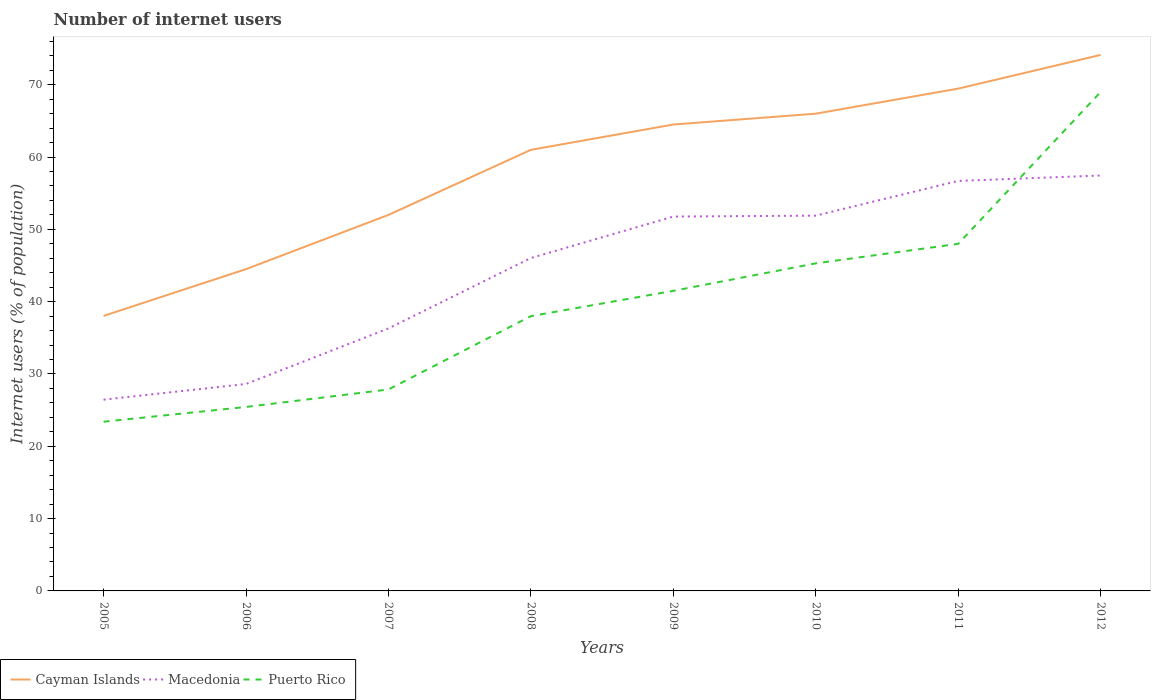Is the number of lines equal to the number of legend labels?
Offer a terse response. Yes. Across all years, what is the maximum number of internet users in Cayman Islands?
Provide a succinct answer. 38.03. What is the total number of internet users in Cayman Islands in the graph?
Offer a terse response. -36.09. What is the difference between the highest and the second highest number of internet users in Macedonia?
Provide a succinct answer. 31. What is the difference between the highest and the lowest number of internet users in Macedonia?
Offer a terse response. 5. Is the number of internet users in Macedonia strictly greater than the number of internet users in Puerto Rico over the years?
Your answer should be compact. No. How many lines are there?
Make the answer very short. 3. How many years are there in the graph?
Ensure brevity in your answer.  8. Are the values on the major ticks of Y-axis written in scientific E-notation?
Offer a very short reply. No. What is the title of the graph?
Your answer should be very brief. Number of internet users. Does "Spain" appear as one of the legend labels in the graph?
Offer a very short reply. No. What is the label or title of the Y-axis?
Ensure brevity in your answer.  Internet users (% of population). What is the Internet users (% of population) of Cayman Islands in 2005?
Offer a very short reply. 38.03. What is the Internet users (% of population) in Macedonia in 2005?
Give a very brief answer. 26.45. What is the Internet users (% of population) in Puerto Rico in 2005?
Offer a terse response. 23.4. What is the Internet users (% of population) of Cayman Islands in 2006?
Ensure brevity in your answer.  44.5. What is the Internet users (% of population) in Macedonia in 2006?
Your answer should be very brief. 28.62. What is the Internet users (% of population) of Puerto Rico in 2006?
Give a very brief answer. 25.44. What is the Internet users (% of population) of Cayman Islands in 2007?
Provide a succinct answer. 52. What is the Internet users (% of population) in Macedonia in 2007?
Give a very brief answer. 36.3. What is the Internet users (% of population) in Puerto Rico in 2007?
Ensure brevity in your answer.  27.86. What is the Internet users (% of population) of Macedonia in 2008?
Your answer should be compact. 46.04. What is the Internet users (% of population) of Puerto Rico in 2008?
Give a very brief answer. 38. What is the Internet users (% of population) in Cayman Islands in 2009?
Your answer should be very brief. 64.5. What is the Internet users (% of population) in Macedonia in 2009?
Offer a terse response. 51.77. What is the Internet users (% of population) in Puerto Rico in 2009?
Offer a terse response. 41.5. What is the Internet users (% of population) in Macedonia in 2010?
Offer a very short reply. 51.9. What is the Internet users (% of population) of Puerto Rico in 2010?
Ensure brevity in your answer.  45.3. What is the Internet users (% of population) of Cayman Islands in 2011?
Ensure brevity in your answer.  69.47. What is the Internet users (% of population) of Macedonia in 2011?
Provide a short and direct response. 56.7. What is the Internet users (% of population) in Cayman Islands in 2012?
Offer a terse response. 74.13. What is the Internet users (% of population) of Macedonia in 2012?
Offer a very short reply. 57.45. What is the Internet users (% of population) in Puerto Rico in 2012?
Provide a short and direct response. 69. Across all years, what is the maximum Internet users (% of population) of Cayman Islands?
Ensure brevity in your answer.  74.13. Across all years, what is the maximum Internet users (% of population) in Macedonia?
Ensure brevity in your answer.  57.45. Across all years, what is the maximum Internet users (% of population) of Puerto Rico?
Keep it short and to the point. 69. Across all years, what is the minimum Internet users (% of population) in Cayman Islands?
Keep it short and to the point. 38.03. Across all years, what is the minimum Internet users (% of population) of Macedonia?
Offer a terse response. 26.45. Across all years, what is the minimum Internet users (% of population) of Puerto Rico?
Your answer should be very brief. 23.4. What is the total Internet users (% of population) in Cayman Islands in the graph?
Give a very brief answer. 469.63. What is the total Internet users (% of population) of Macedonia in the graph?
Provide a succinct answer. 355.23. What is the total Internet users (% of population) of Puerto Rico in the graph?
Your answer should be very brief. 318.5. What is the difference between the Internet users (% of population) in Cayman Islands in 2005 and that in 2006?
Your answer should be very brief. -6.47. What is the difference between the Internet users (% of population) of Macedonia in 2005 and that in 2006?
Give a very brief answer. -2.17. What is the difference between the Internet users (% of population) in Puerto Rico in 2005 and that in 2006?
Your answer should be compact. -2.04. What is the difference between the Internet users (% of population) in Cayman Islands in 2005 and that in 2007?
Keep it short and to the point. -13.97. What is the difference between the Internet users (% of population) of Macedonia in 2005 and that in 2007?
Provide a succinct answer. -9.85. What is the difference between the Internet users (% of population) in Puerto Rico in 2005 and that in 2007?
Your answer should be very brief. -4.46. What is the difference between the Internet users (% of population) in Cayman Islands in 2005 and that in 2008?
Your answer should be compact. -22.97. What is the difference between the Internet users (% of population) in Macedonia in 2005 and that in 2008?
Your answer should be compact. -19.59. What is the difference between the Internet users (% of population) of Puerto Rico in 2005 and that in 2008?
Offer a very short reply. -14.6. What is the difference between the Internet users (% of population) of Cayman Islands in 2005 and that in 2009?
Keep it short and to the point. -26.47. What is the difference between the Internet users (% of population) in Macedonia in 2005 and that in 2009?
Offer a very short reply. -25.32. What is the difference between the Internet users (% of population) in Puerto Rico in 2005 and that in 2009?
Provide a succinct answer. -18.1. What is the difference between the Internet users (% of population) in Cayman Islands in 2005 and that in 2010?
Provide a succinct answer. -27.97. What is the difference between the Internet users (% of population) of Macedonia in 2005 and that in 2010?
Provide a succinct answer. -25.45. What is the difference between the Internet users (% of population) in Puerto Rico in 2005 and that in 2010?
Provide a short and direct response. -21.9. What is the difference between the Internet users (% of population) in Cayman Islands in 2005 and that in 2011?
Offer a very short reply. -31.43. What is the difference between the Internet users (% of population) of Macedonia in 2005 and that in 2011?
Your answer should be very brief. -30.25. What is the difference between the Internet users (% of population) of Puerto Rico in 2005 and that in 2011?
Make the answer very short. -24.6. What is the difference between the Internet users (% of population) of Cayman Islands in 2005 and that in 2012?
Provide a succinct answer. -36.09. What is the difference between the Internet users (% of population) in Macedonia in 2005 and that in 2012?
Your answer should be very brief. -31. What is the difference between the Internet users (% of population) of Puerto Rico in 2005 and that in 2012?
Ensure brevity in your answer.  -45.6. What is the difference between the Internet users (% of population) in Macedonia in 2006 and that in 2007?
Your answer should be compact. -7.68. What is the difference between the Internet users (% of population) in Puerto Rico in 2006 and that in 2007?
Offer a terse response. -2.42. What is the difference between the Internet users (% of population) in Cayman Islands in 2006 and that in 2008?
Your answer should be compact. -16.5. What is the difference between the Internet users (% of population) in Macedonia in 2006 and that in 2008?
Provide a short and direct response. -17.42. What is the difference between the Internet users (% of population) in Puerto Rico in 2006 and that in 2008?
Ensure brevity in your answer.  -12.56. What is the difference between the Internet users (% of population) of Cayman Islands in 2006 and that in 2009?
Offer a very short reply. -20. What is the difference between the Internet users (% of population) in Macedonia in 2006 and that in 2009?
Provide a short and direct response. -23.15. What is the difference between the Internet users (% of population) of Puerto Rico in 2006 and that in 2009?
Give a very brief answer. -16.06. What is the difference between the Internet users (% of population) of Cayman Islands in 2006 and that in 2010?
Your answer should be compact. -21.5. What is the difference between the Internet users (% of population) in Macedonia in 2006 and that in 2010?
Your response must be concise. -23.28. What is the difference between the Internet users (% of population) in Puerto Rico in 2006 and that in 2010?
Give a very brief answer. -19.86. What is the difference between the Internet users (% of population) in Cayman Islands in 2006 and that in 2011?
Offer a terse response. -24.97. What is the difference between the Internet users (% of population) in Macedonia in 2006 and that in 2011?
Give a very brief answer. -28.08. What is the difference between the Internet users (% of population) in Puerto Rico in 2006 and that in 2011?
Your answer should be very brief. -22.56. What is the difference between the Internet users (% of population) in Cayman Islands in 2006 and that in 2012?
Provide a short and direct response. -29.63. What is the difference between the Internet users (% of population) of Macedonia in 2006 and that in 2012?
Provide a short and direct response. -28.83. What is the difference between the Internet users (% of population) of Puerto Rico in 2006 and that in 2012?
Give a very brief answer. -43.56. What is the difference between the Internet users (% of population) in Cayman Islands in 2007 and that in 2008?
Your response must be concise. -9. What is the difference between the Internet users (% of population) in Macedonia in 2007 and that in 2008?
Give a very brief answer. -9.74. What is the difference between the Internet users (% of population) of Puerto Rico in 2007 and that in 2008?
Provide a succinct answer. -10.14. What is the difference between the Internet users (% of population) in Macedonia in 2007 and that in 2009?
Keep it short and to the point. -15.47. What is the difference between the Internet users (% of population) in Puerto Rico in 2007 and that in 2009?
Keep it short and to the point. -13.64. What is the difference between the Internet users (% of population) in Cayman Islands in 2007 and that in 2010?
Offer a terse response. -14. What is the difference between the Internet users (% of population) of Macedonia in 2007 and that in 2010?
Make the answer very short. -15.6. What is the difference between the Internet users (% of population) of Puerto Rico in 2007 and that in 2010?
Provide a succinct answer. -17.44. What is the difference between the Internet users (% of population) in Cayman Islands in 2007 and that in 2011?
Keep it short and to the point. -17.47. What is the difference between the Internet users (% of population) of Macedonia in 2007 and that in 2011?
Provide a short and direct response. -20.4. What is the difference between the Internet users (% of population) of Puerto Rico in 2007 and that in 2011?
Ensure brevity in your answer.  -20.14. What is the difference between the Internet users (% of population) of Cayman Islands in 2007 and that in 2012?
Provide a succinct answer. -22.13. What is the difference between the Internet users (% of population) of Macedonia in 2007 and that in 2012?
Provide a succinct answer. -21.15. What is the difference between the Internet users (% of population) in Puerto Rico in 2007 and that in 2012?
Your answer should be compact. -41.14. What is the difference between the Internet users (% of population) in Macedonia in 2008 and that in 2009?
Your response must be concise. -5.73. What is the difference between the Internet users (% of population) in Puerto Rico in 2008 and that in 2009?
Give a very brief answer. -3.5. What is the difference between the Internet users (% of population) of Cayman Islands in 2008 and that in 2010?
Your answer should be very brief. -5. What is the difference between the Internet users (% of population) of Macedonia in 2008 and that in 2010?
Your response must be concise. -5.86. What is the difference between the Internet users (% of population) of Puerto Rico in 2008 and that in 2010?
Your answer should be very brief. -7.3. What is the difference between the Internet users (% of population) of Cayman Islands in 2008 and that in 2011?
Make the answer very short. -8.47. What is the difference between the Internet users (% of population) in Macedonia in 2008 and that in 2011?
Offer a terse response. -10.66. What is the difference between the Internet users (% of population) of Cayman Islands in 2008 and that in 2012?
Offer a terse response. -13.13. What is the difference between the Internet users (% of population) in Macedonia in 2008 and that in 2012?
Give a very brief answer. -11.41. What is the difference between the Internet users (% of population) of Puerto Rico in 2008 and that in 2012?
Offer a very short reply. -31. What is the difference between the Internet users (% of population) in Cayman Islands in 2009 and that in 2010?
Offer a terse response. -1.5. What is the difference between the Internet users (% of population) in Macedonia in 2009 and that in 2010?
Ensure brevity in your answer.  -0.13. What is the difference between the Internet users (% of population) of Cayman Islands in 2009 and that in 2011?
Offer a very short reply. -4.97. What is the difference between the Internet users (% of population) of Macedonia in 2009 and that in 2011?
Ensure brevity in your answer.  -4.93. What is the difference between the Internet users (% of population) in Cayman Islands in 2009 and that in 2012?
Ensure brevity in your answer.  -9.63. What is the difference between the Internet users (% of population) of Macedonia in 2009 and that in 2012?
Make the answer very short. -5.68. What is the difference between the Internet users (% of population) of Puerto Rico in 2009 and that in 2012?
Give a very brief answer. -27.5. What is the difference between the Internet users (% of population) of Cayman Islands in 2010 and that in 2011?
Your answer should be very brief. -3.47. What is the difference between the Internet users (% of population) in Macedonia in 2010 and that in 2011?
Your answer should be compact. -4.8. What is the difference between the Internet users (% of population) of Cayman Islands in 2010 and that in 2012?
Keep it short and to the point. -8.13. What is the difference between the Internet users (% of population) of Macedonia in 2010 and that in 2012?
Keep it short and to the point. -5.55. What is the difference between the Internet users (% of population) in Puerto Rico in 2010 and that in 2012?
Give a very brief answer. -23.7. What is the difference between the Internet users (% of population) of Cayman Islands in 2011 and that in 2012?
Offer a very short reply. -4.66. What is the difference between the Internet users (% of population) in Macedonia in 2011 and that in 2012?
Keep it short and to the point. -0.75. What is the difference between the Internet users (% of population) of Cayman Islands in 2005 and the Internet users (% of population) of Macedonia in 2006?
Provide a short and direct response. 9.41. What is the difference between the Internet users (% of population) of Cayman Islands in 2005 and the Internet users (% of population) of Puerto Rico in 2006?
Your response must be concise. 12.59. What is the difference between the Internet users (% of population) in Macedonia in 2005 and the Internet users (% of population) in Puerto Rico in 2006?
Give a very brief answer. 1.01. What is the difference between the Internet users (% of population) in Cayman Islands in 2005 and the Internet users (% of population) in Macedonia in 2007?
Keep it short and to the point. 1.73. What is the difference between the Internet users (% of population) in Cayman Islands in 2005 and the Internet users (% of population) in Puerto Rico in 2007?
Ensure brevity in your answer.  10.17. What is the difference between the Internet users (% of population) in Macedonia in 2005 and the Internet users (% of population) in Puerto Rico in 2007?
Your answer should be very brief. -1.41. What is the difference between the Internet users (% of population) in Cayman Islands in 2005 and the Internet users (% of population) in Macedonia in 2008?
Keep it short and to the point. -8.01. What is the difference between the Internet users (% of population) in Cayman Islands in 2005 and the Internet users (% of population) in Puerto Rico in 2008?
Give a very brief answer. 0.03. What is the difference between the Internet users (% of population) in Macedonia in 2005 and the Internet users (% of population) in Puerto Rico in 2008?
Your response must be concise. -11.55. What is the difference between the Internet users (% of population) in Cayman Islands in 2005 and the Internet users (% of population) in Macedonia in 2009?
Make the answer very short. -13.74. What is the difference between the Internet users (% of population) of Cayman Islands in 2005 and the Internet users (% of population) of Puerto Rico in 2009?
Your answer should be compact. -3.47. What is the difference between the Internet users (% of population) of Macedonia in 2005 and the Internet users (% of population) of Puerto Rico in 2009?
Provide a short and direct response. -15.05. What is the difference between the Internet users (% of population) in Cayman Islands in 2005 and the Internet users (% of population) in Macedonia in 2010?
Your response must be concise. -13.87. What is the difference between the Internet users (% of population) of Cayman Islands in 2005 and the Internet users (% of population) of Puerto Rico in 2010?
Your response must be concise. -7.27. What is the difference between the Internet users (% of population) of Macedonia in 2005 and the Internet users (% of population) of Puerto Rico in 2010?
Keep it short and to the point. -18.85. What is the difference between the Internet users (% of population) of Cayman Islands in 2005 and the Internet users (% of population) of Macedonia in 2011?
Offer a terse response. -18.67. What is the difference between the Internet users (% of population) of Cayman Islands in 2005 and the Internet users (% of population) of Puerto Rico in 2011?
Ensure brevity in your answer.  -9.97. What is the difference between the Internet users (% of population) of Macedonia in 2005 and the Internet users (% of population) of Puerto Rico in 2011?
Make the answer very short. -21.55. What is the difference between the Internet users (% of population) in Cayman Islands in 2005 and the Internet users (% of population) in Macedonia in 2012?
Provide a short and direct response. -19.42. What is the difference between the Internet users (% of population) in Cayman Islands in 2005 and the Internet users (% of population) in Puerto Rico in 2012?
Offer a terse response. -30.97. What is the difference between the Internet users (% of population) in Macedonia in 2005 and the Internet users (% of population) in Puerto Rico in 2012?
Your response must be concise. -42.55. What is the difference between the Internet users (% of population) of Cayman Islands in 2006 and the Internet users (% of population) of Macedonia in 2007?
Offer a terse response. 8.2. What is the difference between the Internet users (% of population) of Cayman Islands in 2006 and the Internet users (% of population) of Puerto Rico in 2007?
Give a very brief answer. 16.64. What is the difference between the Internet users (% of population) in Macedonia in 2006 and the Internet users (% of population) in Puerto Rico in 2007?
Offer a terse response. 0.76. What is the difference between the Internet users (% of population) of Cayman Islands in 2006 and the Internet users (% of population) of Macedonia in 2008?
Your answer should be compact. -1.54. What is the difference between the Internet users (% of population) of Cayman Islands in 2006 and the Internet users (% of population) of Puerto Rico in 2008?
Provide a short and direct response. 6.5. What is the difference between the Internet users (% of population) of Macedonia in 2006 and the Internet users (% of population) of Puerto Rico in 2008?
Your response must be concise. -9.38. What is the difference between the Internet users (% of population) of Cayman Islands in 2006 and the Internet users (% of population) of Macedonia in 2009?
Your answer should be compact. -7.27. What is the difference between the Internet users (% of population) of Macedonia in 2006 and the Internet users (% of population) of Puerto Rico in 2009?
Ensure brevity in your answer.  -12.88. What is the difference between the Internet users (% of population) in Macedonia in 2006 and the Internet users (% of population) in Puerto Rico in 2010?
Offer a terse response. -16.68. What is the difference between the Internet users (% of population) in Cayman Islands in 2006 and the Internet users (% of population) in Macedonia in 2011?
Provide a succinct answer. -12.2. What is the difference between the Internet users (% of population) in Macedonia in 2006 and the Internet users (% of population) in Puerto Rico in 2011?
Your answer should be compact. -19.38. What is the difference between the Internet users (% of population) in Cayman Islands in 2006 and the Internet users (% of population) in Macedonia in 2012?
Make the answer very short. -12.95. What is the difference between the Internet users (% of population) in Cayman Islands in 2006 and the Internet users (% of population) in Puerto Rico in 2012?
Give a very brief answer. -24.5. What is the difference between the Internet users (% of population) of Macedonia in 2006 and the Internet users (% of population) of Puerto Rico in 2012?
Provide a short and direct response. -40.38. What is the difference between the Internet users (% of population) in Cayman Islands in 2007 and the Internet users (% of population) in Macedonia in 2008?
Offer a terse response. 5.96. What is the difference between the Internet users (% of population) of Cayman Islands in 2007 and the Internet users (% of population) of Puerto Rico in 2008?
Your response must be concise. 14. What is the difference between the Internet users (% of population) of Cayman Islands in 2007 and the Internet users (% of population) of Macedonia in 2009?
Ensure brevity in your answer.  0.23. What is the difference between the Internet users (% of population) of Cayman Islands in 2007 and the Internet users (% of population) of Puerto Rico in 2009?
Provide a short and direct response. 10.5. What is the difference between the Internet users (% of population) of Cayman Islands in 2007 and the Internet users (% of population) of Puerto Rico in 2010?
Ensure brevity in your answer.  6.7. What is the difference between the Internet users (% of population) of Macedonia in 2007 and the Internet users (% of population) of Puerto Rico in 2010?
Provide a succinct answer. -9. What is the difference between the Internet users (% of population) of Cayman Islands in 2007 and the Internet users (% of population) of Macedonia in 2012?
Your response must be concise. -5.45. What is the difference between the Internet users (% of population) in Macedonia in 2007 and the Internet users (% of population) in Puerto Rico in 2012?
Your answer should be very brief. -32.7. What is the difference between the Internet users (% of population) in Cayman Islands in 2008 and the Internet users (% of population) in Macedonia in 2009?
Provide a succinct answer. 9.23. What is the difference between the Internet users (% of population) in Macedonia in 2008 and the Internet users (% of population) in Puerto Rico in 2009?
Make the answer very short. 4.54. What is the difference between the Internet users (% of population) in Macedonia in 2008 and the Internet users (% of population) in Puerto Rico in 2010?
Your answer should be compact. 0.74. What is the difference between the Internet users (% of population) of Cayman Islands in 2008 and the Internet users (% of population) of Macedonia in 2011?
Provide a succinct answer. 4.3. What is the difference between the Internet users (% of population) of Cayman Islands in 2008 and the Internet users (% of population) of Puerto Rico in 2011?
Keep it short and to the point. 13. What is the difference between the Internet users (% of population) of Macedonia in 2008 and the Internet users (% of population) of Puerto Rico in 2011?
Provide a succinct answer. -1.96. What is the difference between the Internet users (% of population) of Cayman Islands in 2008 and the Internet users (% of population) of Macedonia in 2012?
Offer a terse response. 3.55. What is the difference between the Internet users (% of population) in Cayman Islands in 2008 and the Internet users (% of population) in Puerto Rico in 2012?
Give a very brief answer. -8. What is the difference between the Internet users (% of population) of Macedonia in 2008 and the Internet users (% of population) of Puerto Rico in 2012?
Provide a short and direct response. -22.96. What is the difference between the Internet users (% of population) of Macedonia in 2009 and the Internet users (% of population) of Puerto Rico in 2010?
Offer a terse response. 6.47. What is the difference between the Internet users (% of population) of Cayman Islands in 2009 and the Internet users (% of population) of Macedonia in 2011?
Your response must be concise. 7.8. What is the difference between the Internet users (% of population) of Macedonia in 2009 and the Internet users (% of population) of Puerto Rico in 2011?
Provide a succinct answer. 3.77. What is the difference between the Internet users (% of population) in Cayman Islands in 2009 and the Internet users (% of population) in Macedonia in 2012?
Make the answer very short. 7.05. What is the difference between the Internet users (% of population) of Macedonia in 2009 and the Internet users (% of population) of Puerto Rico in 2012?
Your answer should be very brief. -17.23. What is the difference between the Internet users (% of population) in Cayman Islands in 2010 and the Internet users (% of population) in Macedonia in 2011?
Give a very brief answer. 9.3. What is the difference between the Internet users (% of population) in Macedonia in 2010 and the Internet users (% of population) in Puerto Rico in 2011?
Provide a short and direct response. 3.9. What is the difference between the Internet users (% of population) in Cayman Islands in 2010 and the Internet users (% of population) in Macedonia in 2012?
Offer a terse response. 8.55. What is the difference between the Internet users (% of population) of Macedonia in 2010 and the Internet users (% of population) of Puerto Rico in 2012?
Offer a very short reply. -17.1. What is the difference between the Internet users (% of population) in Cayman Islands in 2011 and the Internet users (% of population) in Macedonia in 2012?
Your answer should be compact. 12.02. What is the difference between the Internet users (% of population) of Cayman Islands in 2011 and the Internet users (% of population) of Puerto Rico in 2012?
Make the answer very short. 0.47. What is the average Internet users (% of population) in Cayman Islands per year?
Provide a short and direct response. 58.7. What is the average Internet users (% of population) of Macedonia per year?
Make the answer very short. 44.4. What is the average Internet users (% of population) in Puerto Rico per year?
Offer a terse response. 39.81. In the year 2005, what is the difference between the Internet users (% of population) in Cayman Islands and Internet users (% of population) in Macedonia?
Your answer should be compact. 11.58. In the year 2005, what is the difference between the Internet users (% of population) in Cayman Islands and Internet users (% of population) in Puerto Rico?
Your answer should be very brief. 14.63. In the year 2005, what is the difference between the Internet users (% of population) in Macedonia and Internet users (% of population) in Puerto Rico?
Keep it short and to the point. 3.05. In the year 2006, what is the difference between the Internet users (% of population) of Cayman Islands and Internet users (% of population) of Macedonia?
Your response must be concise. 15.88. In the year 2006, what is the difference between the Internet users (% of population) in Cayman Islands and Internet users (% of population) in Puerto Rico?
Keep it short and to the point. 19.06. In the year 2006, what is the difference between the Internet users (% of population) in Macedonia and Internet users (% of population) in Puerto Rico?
Provide a succinct answer. 3.18. In the year 2007, what is the difference between the Internet users (% of population) of Cayman Islands and Internet users (% of population) of Macedonia?
Offer a terse response. 15.7. In the year 2007, what is the difference between the Internet users (% of population) of Cayman Islands and Internet users (% of population) of Puerto Rico?
Provide a succinct answer. 24.14. In the year 2007, what is the difference between the Internet users (% of population) in Macedonia and Internet users (% of population) in Puerto Rico?
Offer a very short reply. 8.44. In the year 2008, what is the difference between the Internet users (% of population) of Cayman Islands and Internet users (% of population) of Macedonia?
Offer a very short reply. 14.96. In the year 2008, what is the difference between the Internet users (% of population) in Cayman Islands and Internet users (% of population) in Puerto Rico?
Provide a succinct answer. 23. In the year 2008, what is the difference between the Internet users (% of population) of Macedonia and Internet users (% of population) of Puerto Rico?
Provide a succinct answer. 8.04. In the year 2009, what is the difference between the Internet users (% of population) of Cayman Islands and Internet users (% of population) of Macedonia?
Offer a very short reply. 12.73. In the year 2009, what is the difference between the Internet users (% of population) in Macedonia and Internet users (% of population) in Puerto Rico?
Provide a succinct answer. 10.27. In the year 2010, what is the difference between the Internet users (% of population) in Cayman Islands and Internet users (% of population) in Macedonia?
Provide a short and direct response. 14.1. In the year 2010, what is the difference between the Internet users (% of population) of Cayman Islands and Internet users (% of population) of Puerto Rico?
Provide a succinct answer. 20.7. In the year 2011, what is the difference between the Internet users (% of population) in Cayman Islands and Internet users (% of population) in Macedonia?
Provide a succinct answer. 12.77. In the year 2011, what is the difference between the Internet users (% of population) in Cayman Islands and Internet users (% of population) in Puerto Rico?
Provide a succinct answer. 21.47. In the year 2012, what is the difference between the Internet users (% of population) in Cayman Islands and Internet users (% of population) in Macedonia?
Offer a very short reply. 16.68. In the year 2012, what is the difference between the Internet users (% of population) in Cayman Islands and Internet users (% of population) in Puerto Rico?
Your response must be concise. 5.13. In the year 2012, what is the difference between the Internet users (% of population) of Macedonia and Internet users (% of population) of Puerto Rico?
Ensure brevity in your answer.  -11.55. What is the ratio of the Internet users (% of population) in Cayman Islands in 2005 to that in 2006?
Ensure brevity in your answer.  0.85. What is the ratio of the Internet users (% of population) of Macedonia in 2005 to that in 2006?
Make the answer very short. 0.92. What is the ratio of the Internet users (% of population) of Puerto Rico in 2005 to that in 2006?
Ensure brevity in your answer.  0.92. What is the ratio of the Internet users (% of population) of Cayman Islands in 2005 to that in 2007?
Offer a very short reply. 0.73. What is the ratio of the Internet users (% of population) of Macedonia in 2005 to that in 2007?
Offer a terse response. 0.73. What is the ratio of the Internet users (% of population) in Puerto Rico in 2005 to that in 2007?
Offer a very short reply. 0.84. What is the ratio of the Internet users (% of population) of Cayman Islands in 2005 to that in 2008?
Offer a terse response. 0.62. What is the ratio of the Internet users (% of population) of Macedonia in 2005 to that in 2008?
Your answer should be very brief. 0.57. What is the ratio of the Internet users (% of population) of Puerto Rico in 2005 to that in 2008?
Ensure brevity in your answer.  0.62. What is the ratio of the Internet users (% of population) in Cayman Islands in 2005 to that in 2009?
Offer a terse response. 0.59. What is the ratio of the Internet users (% of population) in Macedonia in 2005 to that in 2009?
Your answer should be very brief. 0.51. What is the ratio of the Internet users (% of population) of Puerto Rico in 2005 to that in 2009?
Offer a very short reply. 0.56. What is the ratio of the Internet users (% of population) of Cayman Islands in 2005 to that in 2010?
Offer a terse response. 0.58. What is the ratio of the Internet users (% of population) in Macedonia in 2005 to that in 2010?
Provide a succinct answer. 0.51. What is the ratio of the Internet users (% of population) in Puerto Rico in 2005 to that in 2010?
Offer a very short reply. 0.52. What is the ratio of the Internet users (% of population) of Cayman Islands in 2005 to that in 2011?
Your response must be concise. 0.55. What is the ratio of the Internet users (% of population) of Macedonia in 2005 to that in 2011?
Your answer should be compact. 0.47. What is the ratio of the Internet users (% of population) of Puerto Rico in 2005 to that in 2011?
Keep it short and to the point. 0.49. What is the ratio of the Internet users (% of population) of Cayman Islands in 2005 to that in 2012?
Keep it short and to the point. 0.51. What is the ratio of the Internet users (% of population) in Macedonia in 2005 to that in 2012?
Offer a terse response. 0.46. What is the ratio of the Internet users (% of population) in Puerto Rico in 2005 to that in 2012?
Offer a very short reply. 0.34. What is the ratio of the Internet users (% of population) of Cayman Islands in 2006 to that in 2007?
Offer a very short reply. 0.86. What is the ratio of the Internet users (% of population) in Macedonia in 2006 to that in 2007?
Keep it short and to the point. 0.79. What is the ratio of the Internet users (% of population) in Puerto Rico in 2006 to that in 2007?
Offer a very short reply. 0.91. What is the ratio of the Internet users (% of population) of Cayman Islands in 2006 to that in 2008?
Provide a short and direct response. 0.73. What is the ratio of the Internet users (% of population) in Macedonia in 2006 to that in 2008?
Offer a terse response. 0.62. What is the ratio of the Internet users (% of population) in Puerto Rico in 2006 to that in 2008?
Provide a succinct answer. 0.67. What is the ratio of the Internet users (% of population) in Cayman Islands in 2006 to that in 2009?
Your answer should be compact. 0.69. What is the ratio of the Internet users (% of population) of Macedonia in 2006 to that in 2009?
Your answer should be very brief. 0.55. What is the ratio of the Internet users (% of population) of Puerto Rico in 2006 to that in 2009?
Offer a very short reply. 0.61. What is the ratio of the Internet users (% of population) of Cayman Islands in 2006 to that in 2010?
Give a very brief answer. 0.67. What is the ratio of the Internet users (% of population) of Macedonia in 2006 to that in 2010?
Provide a succinct answer. 0.55. What is the ratio of the Internet users (% of population) in Puerto Rico in 2006 to that in 2010?
Give a very brief answer. 0.56. What is the ratio of the Internet users (% of population) of Cayman Islands in 2006 to that in 2011?
Your answer should be compact. 0.64. What is the ratio of the Internet users (% of population) of Macedonia in 2006 to that in 2011?
Your answer should be very brief. 0.5. What is the ratio of the Internet users (% of population) of Puerto Rico in 2006 to that in 2011?
Keep it short and to the point. 0.53. What is the ratio of the Internet users (% of population) of Cayman Islands in 2006 to that in 2012?
Offer a very short reply. 0.6. What is the ratio of the Internet users (% of population) in Macedonia in 2006 to that in 2012?
Your answer should be very brief. 0.5. What is the ratio of the Internet users (% of population) in Puerto Rico in 2006 to that in 2012?
Offer a terse response. 0.37. What is the ratio of the Internet users (% of population) of Cayman Islands in 2007 to that in 2008?
Ensure brevity in your answer.  0.85. What is the ratio of the Internet users (% of population) in Macedonia in 2007 to that in 2008?
Your answer should be compact. 0.79. What is the ratio of the Internet users (% of population) in Puerto Rico in 2007 to that in 2008?
Keep it short and to the point. 0.73. What is the ratio of the Internet users (% of population) of Cayman Islands in 2007 to that in 2009?
Offer a very short reply. 0.81. What is the ratio of the Internet users (% of population) in Macedonia in 2007 to that in 2009?
Your answer should be very brief. 0.7. What is the ratio of the Internet users (% of population) in Puerto Rico in 2007 to that in 2009?
Provide a succinct answer. 0.67. What is the ratio of the Internet users (% of population) of Cayman Islands in 2007 to that in 2010?
Ensure brevity in your answer.  0.79. What is the ratio of the Internet users (% of population) of Macedonia in 2007 to that in 2010?
Make the answer very short. 0.7. What is the ratio of the Internet users (% of population) in Puerto Rico in 2007 to that in 2010?
Your answer should be compact. 0.61. What is the ratio of the Internet users (% of population) in Cayman Islands in 2007 to that in 2011?
Ensure brevity in your answer.  0.75. What is the ratio of the Internet users (% of population) in Macedonia in 2007 to that in 2011?
Your answer should be very brief. 0.64. What is the ratio of the Internet users (% of population) in Puerto Rico in 2007 to that in 2011?
Provide a short and direct response. 0.58. What is the ratio of the Internet users (% of population) of Cayman Islands in 2007 to that in 2012?
Your response must be concise. 0.7. What is the ratio of the Internet users (% of population) in Macedonia in 2007 to that in 2012?
Your response must be concise. 0.63. What is the ratio of the Internet users (% of population) in Puerto Rico in 2007 to that in 2012?
Make the answer very short. 0.4. What is the ratio of the Internet users (% of population) in Cayman Islands in 2008 to that in 2009?
Offer a terse response. 0.95. What is the ratio of the Internet users (% of population) of Macedonia in 2008 to that in 2009?
Give a very brief answer. 0.89. What is the ratio of the Internet users (% of population) of Puerto Rico in 2008 to that in 2009?
Your answer should be compact. 0.92. What is the ratio of the Internet users (% of population) of Cayman Islands in 2008 to that in 2010?
Give a very brief answer. 0.92. What is the ratio of the Internet users (% of population) in Macedonia in 2008 to that in 2010?
Your answer should be very brief. 0.89. What is the ratio of the Internet users (% of population) in Puerto Rico in 2008 to that in 2010?
Offer a very short reply. 0.84. What is the ratio of the Internet users (% of population) of Cayman Islands in 2008 to that in 2011?
Your answer should be compact. 0.88. What is the ratio of the Internet users (% of population) of Macedonia in 2008 to that in 2011?
Your answer should be very brief. 0.81. What is the ratio of the Internet users (% of population) in Puerto Rico in 2008 to that in 2011?
Your answer should be compact. 0.79. What is the ratio of the Internet users (% of population) in Cayman Islands in 2008 to that in 2012?
Ensure brevity in your answer.  0.82. What is the ratio of the Internet users (% of population) in Macedonia in 2008 to that in 2012?
Give a very brief answer. 0.8. What is the ratio of the Internet users (% of population) of Puerto Rico in 2008 to that in 2012?
Your response must be concise. 0.55. What is the ratio of the Internet users (% of population) in Cayman Islands in 2009 to that in 2010?
Make the answer very short. 0.98. What is the ratio of the Internet users (% of population) in Macedonia in 2009 to that in 2010?
Keep it short and to the point. 1. What is the ratio of the Internet users (% of population) of Puerto Rico in 2009 to that in 2010?
Make the answer very short. 0.92. What is the ratio of the Internet users (% of population) in Cayman Islands in 2009 to that in 2011?
Your response must be concise. 0.93. What is the ratio of the Internet users (% of population) in Macedonia in 2009 to that in 2011?
Offer a very short reply. 0.91. What is the ratio of the Internet users (% of population) in Puerto Rico in 2009 to that in 2011?
Offer a very short reply. 0.86. What is the ratio of the Internet users (% of population) in Cayman Islands in 2009 to that in 2012?
Ensure brevity in your answer.  0.87. What is the ratio of the Internet users (% of population) in Macedonia in 2009 to that in 2012?
Provide a short and direct response. 0.9. What is the ratio of the Internet users (% of population) in Puerto Rico in 2009 to that in 2012?
Offer a very short reply. 0.6. What is the ratio of the Internet users (% of population) in Cayman Islands in 2010 to that in 2011?
Your answer should be compact. 0.95. What is the ratio of the Internet users (% of population) in Macedonia in 2010 to that in 2011?
Give a very brief answer. 0.92. What is the ratio of the Internet users (% of population) in Puerto Rico in 2010 to that in 2011?
Offer a very short reply. 0.94. What is the ratio of the Internet users (% of population) in Cayman Islands in 2010 to that in 2012?
Keep it short and to the point. 0.89. What is the ratio of the Internet users (% of population) of Macedonia in 2010 to that in 2012?
Your answer should be very brief. 0.9. What is the ratio of the Internet users (% of population) in Puerto Rico in 2010 to that in 2012?
Offer a terse response. 0.66. What is the ratio of the Internet users (% of population) in Cayman Islands in 2011 to that in 2012?
Ensure brevity in your answer.  0.94. What is the ratio of the Internet users (% of population) of Macedonia in 2011 to that in 2012?
Offer a terse response. 0.99. What is the ratio of the Internet users (% of population) of Puerto Rico in 2011 to that in 2012?
Make the answer very short. 0.7. What is the difference between the highest and the second highest Internet users (% of population) of Cayman Islands?
Your answer should be very brief. 4.66. What is the difference between the highest and the second highest Internet users (% of population) of Macedonia?
Make the answer very short. 0.75. What is the difference between the highest and the second highest Internet users (% of population) of Puerto Rico?
Provide a succinct answer. 21. What is the difference between the highest and the lowest Internet users (% of population) of Cayman Islands?
Give a very brief answer. 36.09. What is the difference between the highest and the lowest Internet users (% of population) of Macedonia?
Give a very brief answer. 31. What is the difference between the highest and the lowest Internet users (% of population) in Puerto Rico?
Make the answer very short. 45.6. 